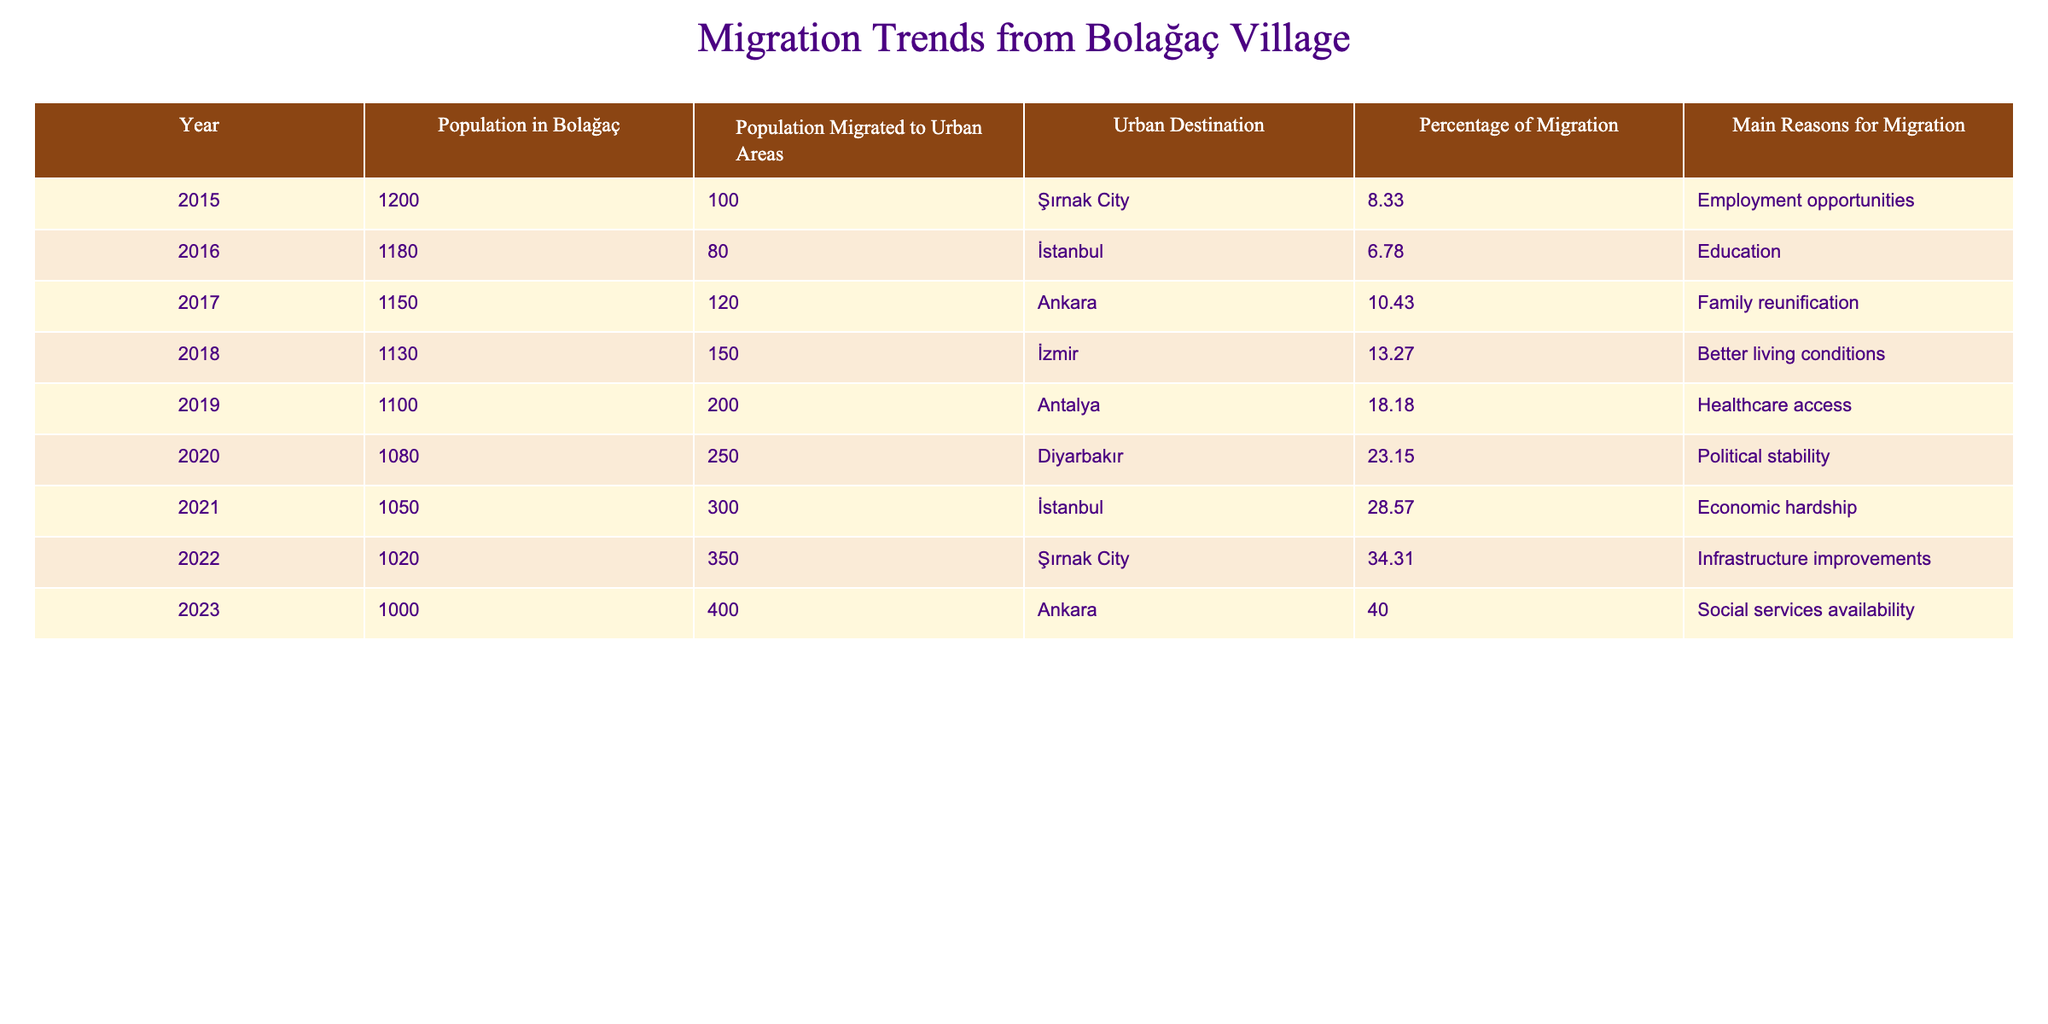What was the population of Bolağaç in 2018? In 2018, the table shows a population of 1130 in Bolağaç.
Answer: 1130 How many people migrated to urban areas in 2020? According to the table, 250 people migrated to urban areas in 2020.
Answer: 250 What was the percentage of migration from Bolağaç in 2021? The table indicates that the percentage of migration in 2021 was 28.57%.
Answer: 28.57% What are the main reasons for migration in 2019? Looking at the table, the main reasons for migration in 2019 were "Healthcare access."
Answer: Healthcare access What is the total population that migrated to urban areas from 2015 to 2023? We need to sum the number of migrants each year from 2015 (100) to 2023 (400). The total is 100 + 80 + 120 + 150 + 200 + 250 + 300 + 350 + 400 = 1950.
Answer: 1950 Is the percentage of migration higher in 2022 compared to 2015? Comparing the two values, in 2022 the percentage of migration was 34.31%, and in 2015 it was 8.33%. Therefore, yes, it is higher.
Answer: Yes What was the urban destination with the highest migration rate in 2023? The data show that the urban destination with the highest migration rate in 2023 was Ankara, with a 40.00% migration rate.
Answer: Ankara Was there a year when the population migrated to urban areas exceeded 300? Yes, according to the table, in 2021 and 2022, more than 300 people migrated to urban areas (300 in 2021 and 350 in 2022).
Answer: Yes What is the average percentage of migration from 2015 to 2023? We calculate the average percentage by summing all percentages (8.33 + 6.78 + 10.43 + 13.27 + 18.18 + 23.15 + 28.57 + 34.31 + 40.00) = 179.02, and then Divide by the number of years (9) giving 179.02 / 9 ≈ 19.89%.
Answer: 19.89% In which year did the migration for "Better living conditions" appear? The table shows that the reason "Better living conditions" for migration appeared in 2018.
Answer: 2018 